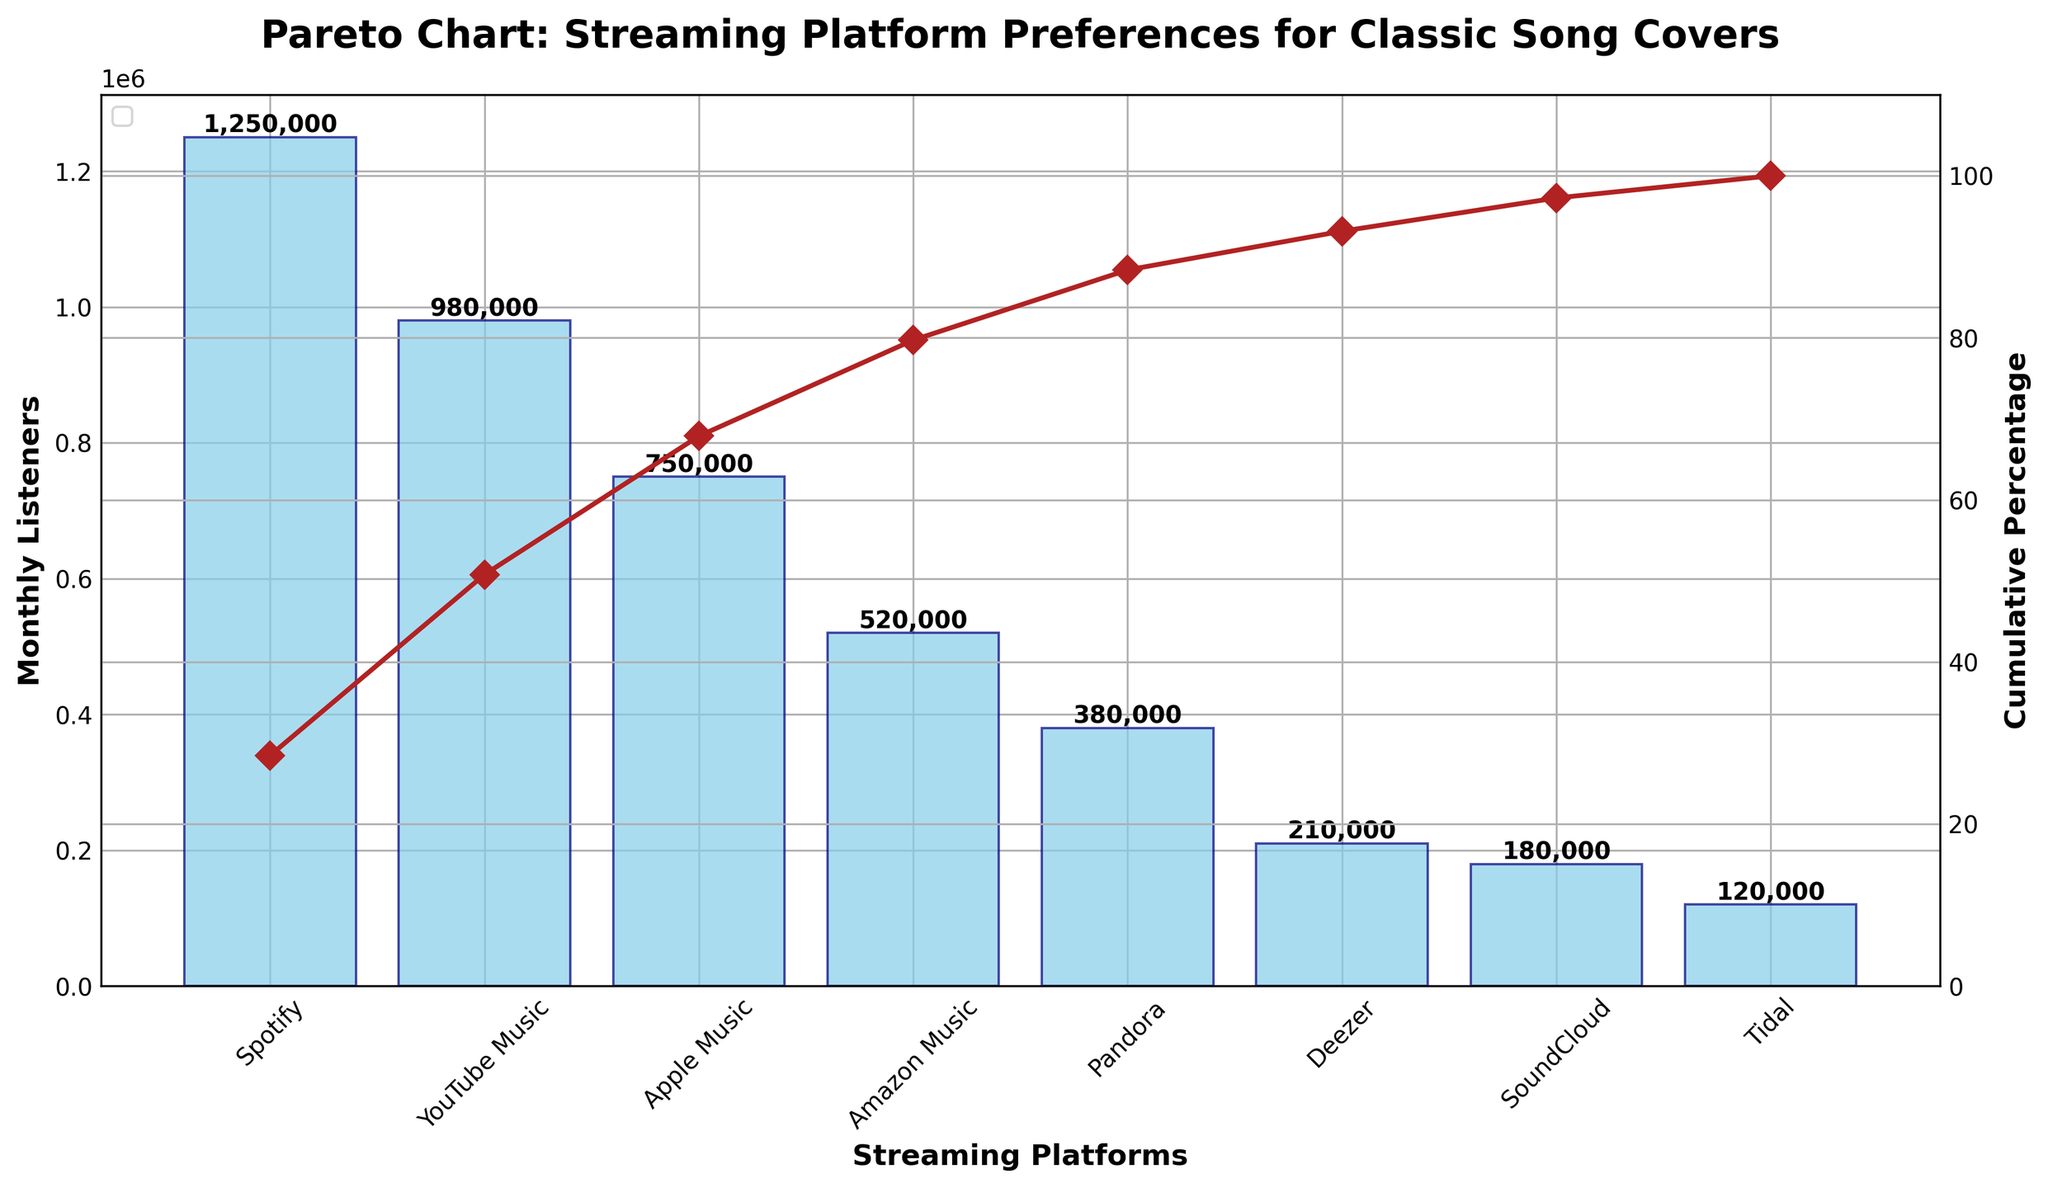What is the platform with the highest number of monthly listeners? The bar representing Spotify is the tallest, indicating it has the highest number of monthly listeners.
Answer: Spotify What is the cumulative percentage after accounting for the listeners from YouTube Music? The cumulative percentage line shows a point corresponding to YouTube Music, which reaches up to about 58%.
Answer: 58% Which platform has fewer monthly listeners, Amazon Music or Pandora? By observing the height of their bars, Pandora's bar is shorter than Amazon Music's bar.
Answer: Pandora What is the total number of monthly listeners across all platforms? Summing the values of all the bars: 1250000 + 980000 + 750000 + 520000 + 380000 + 210000 + 180000 + 120000 = 4400000.
Answer: 4400000 How many platforms have monthly listeners above 500,000? Count the platforms with bars taller than 500,000 listeners: Spotify, YouTube Music, and Apple Music – totaling three.
Answer: 3 What are the cumulative percentages for Spotify and Apple Music, respectively? Observing the cumulative percentage line at the Spotify and Apple Music markers, Spotify is at about 28%, and Apple Music is around 83%.
Answer: 28%, 83% What is the difference in monthly listeners between SoundCloud and Tidal? Subtract Tidal's listener count from SoundCloud's: 180000 - 120000 = 60000.
Answer: 60000 Which platforms cumulatively account for approximately 80% of the total listeners? From the cumulative percentage line, the first four platforms (Spotify, YouTube Music, Apple Music, Amazon Music) together approximate 80%.
Answer: Spotify, YouTube Music, Apple Music, Amazon Music How does the number of listeners of Pandora compare to Deezer? Pandora's bar is taller, indicating it has more listeners than Deezer.
Answer: More What is the average number of monthly listeners across all platforms? Sum the monthly listeners and divide by the number of platforms: (1250000 + 980000 + 750000 + 520000 + 380000 + 210000 + 180000 + 120000) / 8 ≈ 550000.
Answer: 550000 